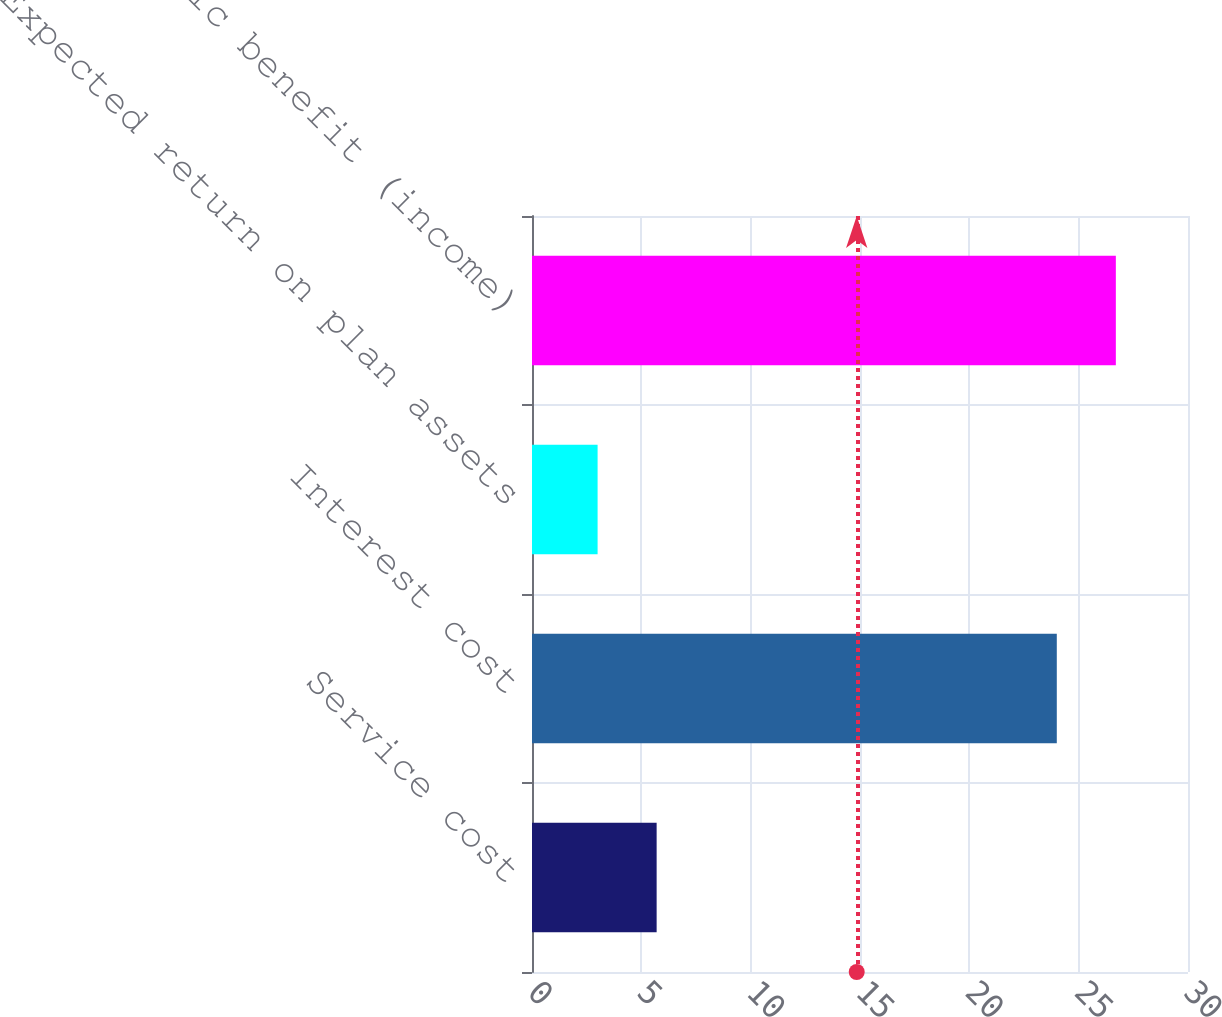Convert chart to OTSL. <chart><loc_0><loc_0><loc_500><loc_500><bar_chart><fcel>Service cost<fcel>Interest cost<fcel>Expected return on plan assets<fcel>Net periodic benefit (income)<nl><fcel>5.7<fcel>24<fcel>3<fcel>26.7<nl></chart> 